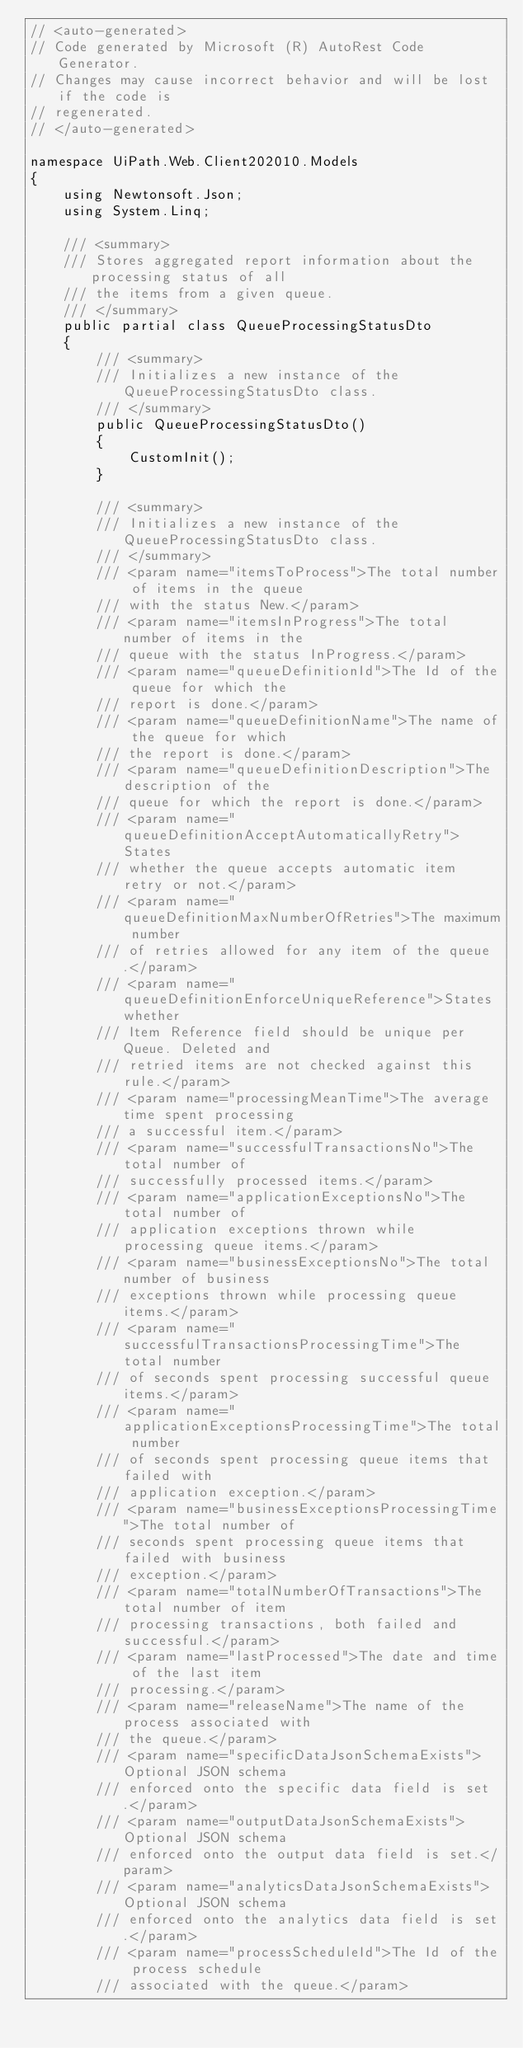Convert code to text. <code><loc_0><loc_0><loc_500><loc_500><_C#_>// <auto-generated>
// Code generated by Microsoft (R) AutoRest Code Generator.
// Changes may cause incorrect behavior and will be lost if the code is
// regenerated.
// </auto-generated>

namespace UiPath.Web.Client202010.Models
{
    using Newtonsoft.Json;
    using System.Linq;

    /// <summary>
    /// Stores aggregated report information about the processing status of all
    /// the items from a given queue.
    /// </summary>
    public partial class QueueProcessingStatusDto
    {
        /// <summary>
        /// Initializes a new instance of the QueueProcessingStatusDto class.
        /// </summary>
        public QueueProcessingStatusDto()
        {
            CustomInit();
        }

        /// <summary>
        /// Initializes a new instance of the QueueProcessingStatusDto class.
        /// </summary>
        /// <param name="itemsToProcess">The total number of items in the queue
        /// with the status New.</param>
        /// <param name="itemsInProgress">The total number of items in the
        /// queue with the status InProgress.</param>
        /// <param name="queueDefinitionId">The Id of the queue for which the
        /// report is done.</param>
        /// <param name="queueDefinitionName">The name of the queue for which
        /// the report is done.</param>
        /// <param name="queueDefinitionDescription">The description of the
        /// queue for which the report is done.</param>
        /// <param name="queueDefinitionAcceptAutomaticallyRetry">States
        /// whether the queue accepts automatic item retry or not.</param>
        /// <param name="queueDefinitionMaxNumberOfRetries">The maximum number
        /// of retries allowed for any item of the queue.</param>
        /// <param name="queueDefinitionEnforceUniqueReference">States whether
        /// Item Reference field should be unique per Queue. Deleted and
        /// retried items are not checked against this rule.</param>
        /// <param name="processingMeanTime">The average time spent processing
        /// a successful item.</param>
        /// <param name="successfulTransactionsNo">The total number of
        /// successfully processed items.</param>
        /// <param name="applicationExceptionsNo">The total number of
        /// application exceptions thrown while processing queue items.</param>
        /// <param name="businessExceptionsNo">The total number of business
        /// exceptions thrown while processing queue items.</param>
        /// <param name="successfulTransactionsProcessingTime">The total number
        /// of seconds spent processing successful queue items.</param>
        /// <param name="applicationExceptionsProcessingTime">The total number
        /// of seconds spent processing queue items that failed with
        /// application exception.</param>
        /// <param name="businessExceptionsProcessingTime">The total number of
        /// seconds spent processing queue items that failed with business
        /// exception.</param>
        /// <param name="totalNumberOfTransactions">The total number of item
        /// processing transactions, both failed and successful.</param>
        /// <param name="lastProcessed">The date and time of the last item
        /// processing.</param>
        /// <param name="releaseName">The name of the process associated with
        /// the queue.</param>
        /// <param name="specificDataJsonSchemaExists">Optional JSON schema
        /// enforced onto the specific data field is set.</param>
        /// <param name="outputDataJsonSchemaExists">Optional JSON schema
        /// enforced onto the output data field is set.</param>
        /// <param name="analyticsDataJsonSchemaExists">Optional JSON schema
        /// enforced onto the analytics data field is set.</param>
        /// <param name="processScheduleId">The Id of the process schedule
        /// associated with the queue.</param></code> 